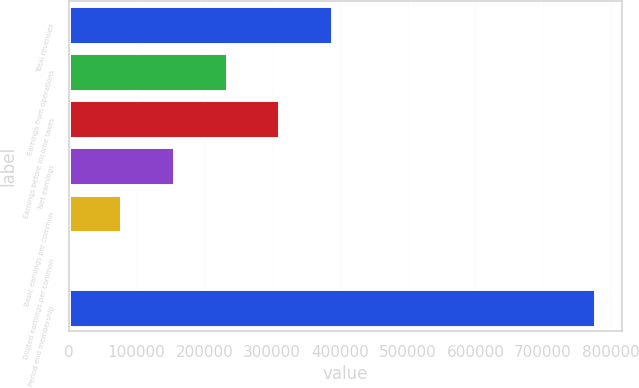<chart> <loc_0><loc_0><loc_500><loc_500><bar_chart><fcel>Total revenues<fcel>Earnings from operations<fcel>Earnings before income taxes<fcel>Net earnings<fcel>Basic earnings per common<fcel>Diluted earnings per common<fcel>Period end membership<nl><fcel>388650<fcel>233190<fcel>310920<fcel>155460<fcel>77730.3<fcel>0.32<fcel>777300<nl></chart> 